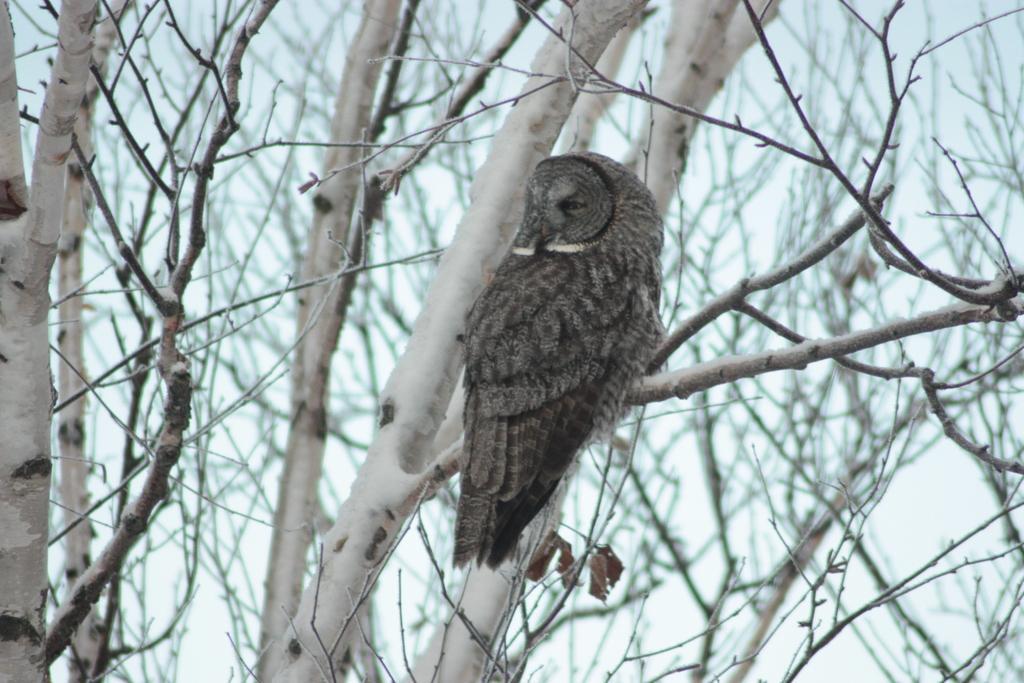Can you describe this image briefly? In this picture we can see an owl on the branch. Behind the owl, there are trees and a blurred background. 